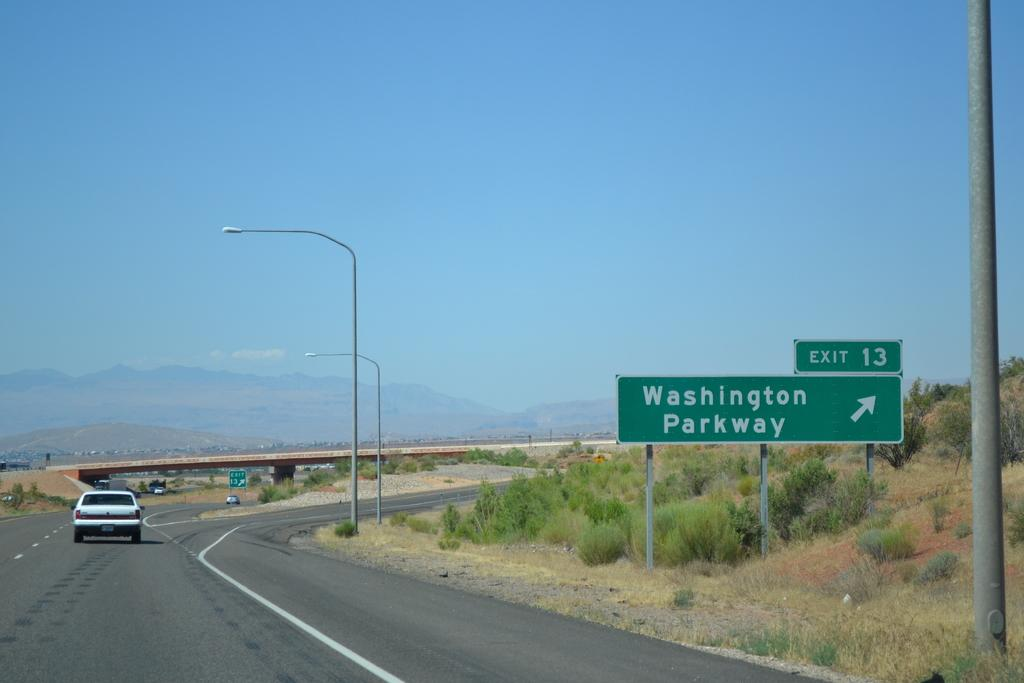<image>
Provide a brief description of the given image. A highway with a sign that says exit 13. washington parkway 